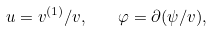Convert formula to latex. <formula><loc_0><loc_0><loc_500><loc_500>u = v ^ { ( 1 ) } / v , \quad \varphi = \partial ( \psi / v ) ,</formula> 